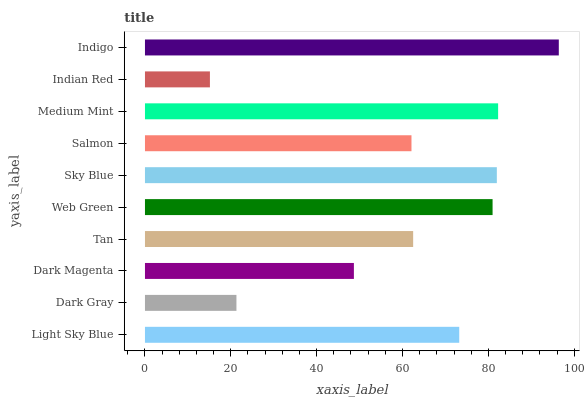Is Indian Red the minimum?
Answer yes or no. Yes. Is Indigo the maximum?
Answer yes or no. Yes. Is Dark Gray the minimum?
Answer yes or no. No. Is Dark Gray the maximum?
Answer yes or no. No. Is Light Sky Blue greater than Dark Gray?
Answer yes or no. Yes. Is Dark Gray less than Light Sky Blue?
Answer yes or no. Yes. Is Dark Gray greater than Light Sky Blue?
Answer yes or no. No. Is Light Sky Blue less than Dark Gray?
Answer yes or no. No. Is Light Sky Blue the high median?
Answer yes or no. Yes. Is Tan the low median?
Answer yes or no. Yes. Is Indian Red the high median?
Answer yes or no. No. Is Light Sky Blue the low median?
Answer yes or no. No. 